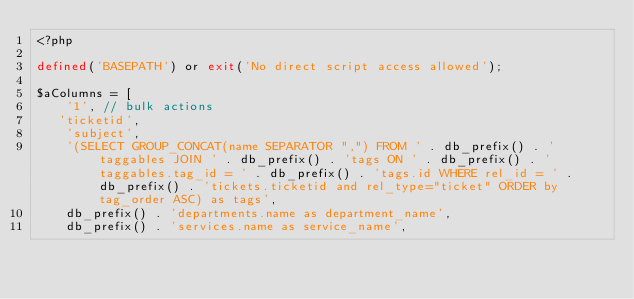Convert code to text. <code><loc_0><loc_0><loc_500><loc_500><_PHP_><?php

defined('BASEPATH') or exit('No direct script access allowed');

$aColumns = [
    '1', // bulk actions
   'ticketid',
    'subject',
    '(SELECT GROUP_CONCAT(name SEPARATOR ",") FROM ' . db_prefix() . 'taggables JOIN ' . db_prefix() . 'tags ON ' . db_prefix() . 'taggables.tag_id = ' . db_prefix() . 'tags.id WHERE rel_id = ' . db_prefix() . 'tickets.ticketid and rel_type="ticket" ORDER by tag_order ASC) as tags',
    db_prefix() . 'departments.name as department_name',
    db_prefix() . 'services.name as service_name',</code> 